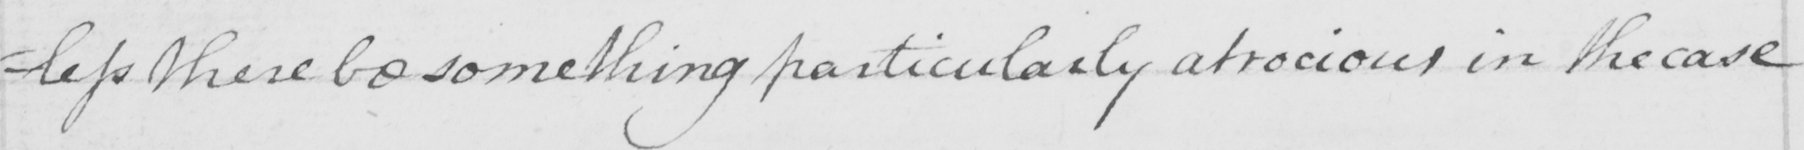Transcribe the text shown in this historical manuscript line. =less these be something particularly atrocious in the case 